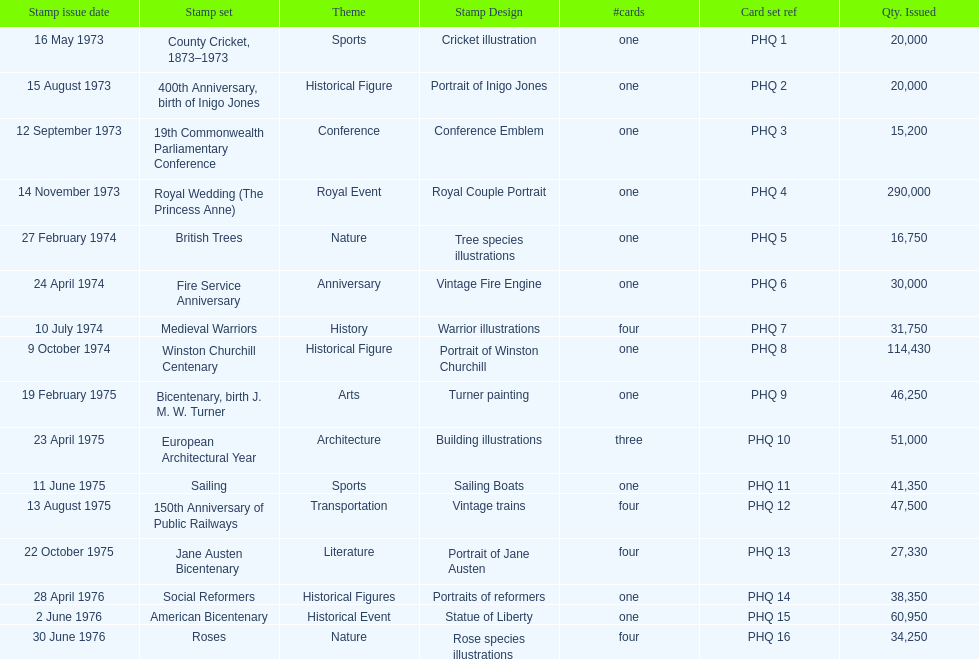Give me the full table as a dictionary. {'header': ['Stamp issue date', 'Stamp set', 'Theme', 'Stamp Design', '#cards', 'Card set ref', 'Qty. Issued'], 'rows': [['16 May 1973', 'County Cricket, 1873–1973', 'Sports', 'Cricket illustration', 'one', 'PHQ 1', '20,000'], ['15 August 1973', '400th Anniversary, birth of Inigo Jones', 'Historical Figure', 'Portrait of Inigo Jones', 'one', 'PHQ 2', '20,000'], ['12 September 1973', '19th Commonwealth Parliamentary Conference', 'Conference', 'Conference Emblem', 'one', 'PHQ 3', '15,200'], ['14 November 1973', 'Royal Wedding (The Princess Anne)', 'Royal Event', 'Royal Couple Portrait', 'one', 'PHQ 4', '290,000'], ['27 February 1974', 'British Trees', 'Nature', 'Tree species illustrations', 'one', 'PHQ 5', '16,750'], ['24 April 1974', 'Fire Service Anniversary', 'Anniversary', 'Vintage Fire Engine', 'one', 'PHQ 6', '30,000'], ['10 July 1974', 'Medieval Warriors', 'History', 'Warrior illustrations', 'four', 'PHQ 7', '31,750'], ['9 October 1974', 'Winston Churchill Centenary', 'Historical Figure', 'Portrait of Winston Churchill', 'one', 'PHQ 8', '114,430'], ['19 February 1975', 'Bicentenary, birth J. M. W. Turner', 'Arts', 'Turner painting', 'one', 'PHQ 9', '46,250'], ['23 April 1975', 'European Architectural Year', 'Architecture', 'Building illustrations', 'three', 'PHQ 10', '51,000'], ['11 June 1975', 'Sailing', 'Sports', 'Sailing Boats', 'one', 'PHQ 11', '41,350'], ['13 August 1975', '150th Anniversary of Public Railways', 'Transportation', 'Vintage trains', 'four', 'PHQ 12', '47,500'], ['22 October 1975', 'Jane Austen Bicentenary', 'Literature', 'Portrait of Jane Austen', 'four', 'PHQ 13', '27,330'], ['28 April 1976', 'Social Reformers', 'Historical Figures', 'Portraits of reformers', 'one', 'PHQ 14', '38,350'], ['2 June 1976', 'American Bicentenary', 'Historical Event', 'Statue of Liberty', 'one', 'PHQ 15', '60,950'], ['30 June 1976', 'Roses', 'Nature', 'Rose species illustrations', 'four', 'PHQ 16', '34,250']]} Which year witnessed the maximum issuance of stamps? 1973. 